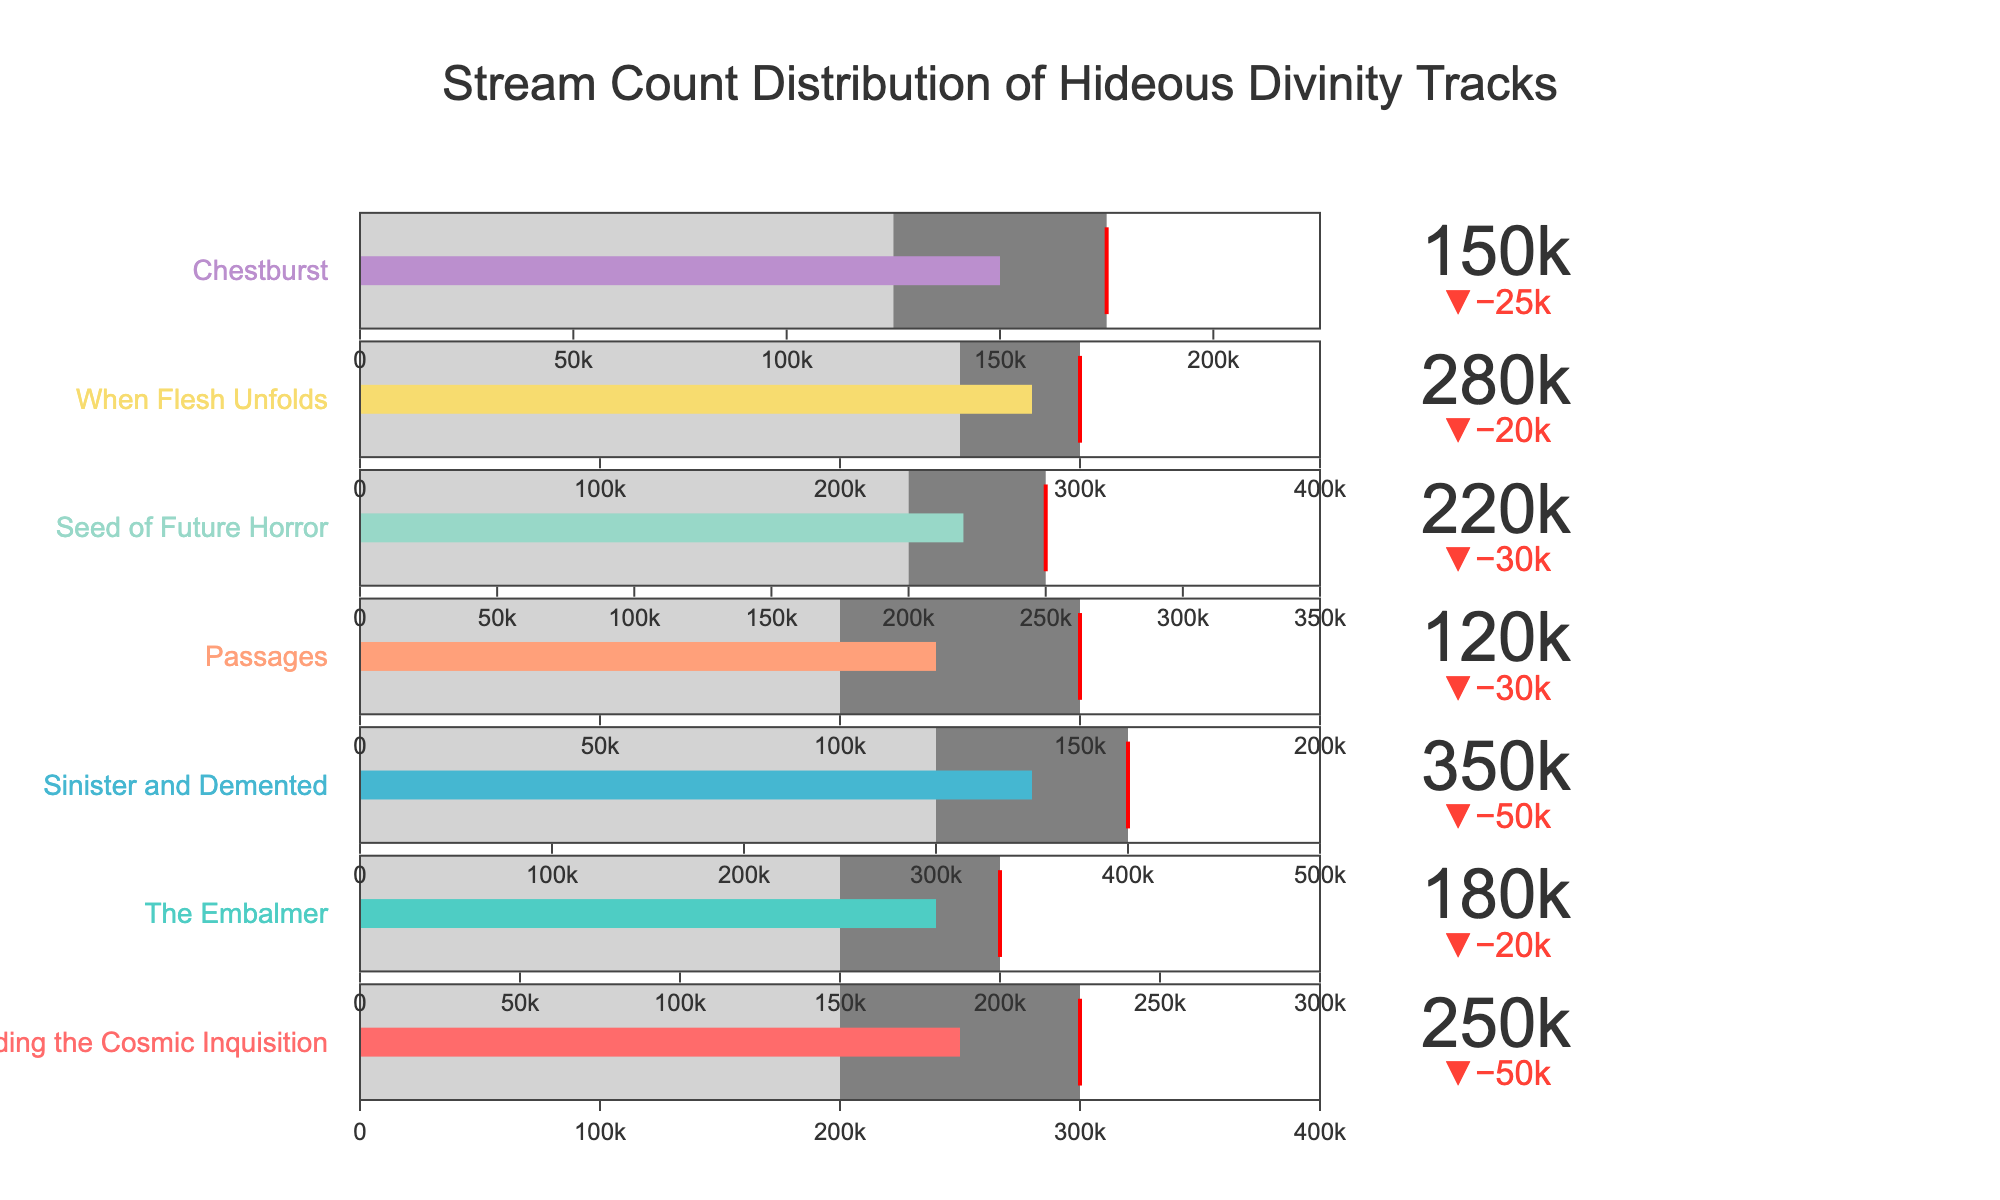What's the title of the bullet chart? The title is usually located at the top center of the figure. It is distinctly different in font size and color.
Answer: Stream Count Distribution of Hideous Divinity Tracks What is the actual stream count for the track "Sinister and Demented"? Look for the labeled bullet gauge corresponding to "Sinister and Demented" and check its value.
Answer: 350,000 How many tracks have actual stream counts below their target? Compare each track’s actual stream count to its target to determine how many are lesser. Tracks: "Spearheading the Cosmic Inquisition", "The Embalmer", "Seed of Future Horror", "When Flesh Unfolds", and "Chestburst". That's 5 out of 7 tracks.
Answer: 5 Which track has the highest maximum stream count? Compare the maximum stream counts for each track to find the highest one. "Sinister and Demented" has a maximum of 500,000 which is the highest.
Answer: Sinister and Demented Which tracks have surpassed their threshold but not their target? Check where the actual stream count is between the threshold and the target. "Spearheading the Cosmic Inquisition", "Seed of Future Horror", "When Flesh Unfolds", and "Chestburst" fall into this range.
Answer: Spearheading the Cosmic Inquisition, Seed of Future Horror, When Flesh Unfolds, Chestburst What is the difference between the actual and target stream counts for "The Embalmer"? Subtract the target stream count from the actual stream count for "The Embalmer" (180,000 - 200,000).
Answer: -20,000 Which track is closest to meeting its target stream count? Determine the track with the smallest absolute difference between its actual streams and target streams. "When Flesh Unfolds" is closest with a difference of only 20,000 (280,000 actual vs. 300,000 target).
Answer: When Flesh Unfolds How many tracks have met or exceeded their targets? Count the tracks where the actual stream count is greater than or equal to the target. Only "Sinister and Demented" meets this criterion.
Answer: 1 Across all tracks, what is the average actual stream count? Sum the actual stream counts and divide by the number of tracks. The total is 1,550,000 across 7 tracks. So, the average is 1,550,000 / 7 ≈ 221,429.
Answer: 221,429 Which track has the smallest stream count threshold? Compare the threshold values across the tracks to find the smallest. "Passages" has the lowest threshold of 100,000.
Answer: Passages 